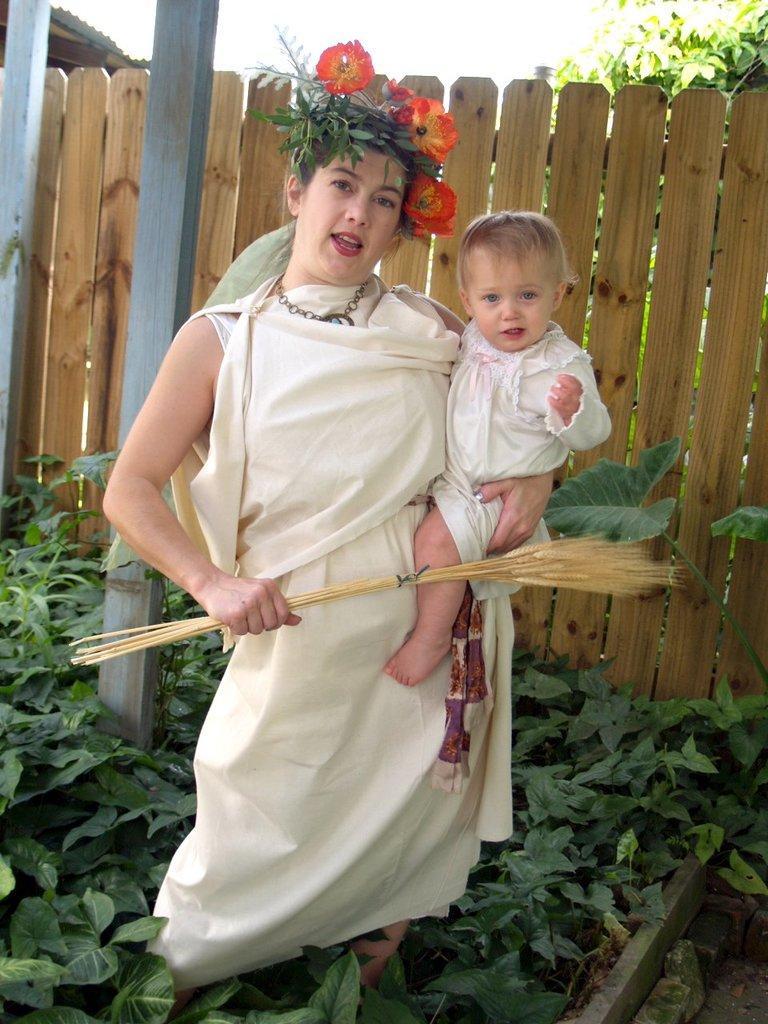Please provide a concise description of this image. This image consists of a woman wearing white dress is holding a baby. At the bottom, there are green plants. In the background, there is a fencing made up of wood. 